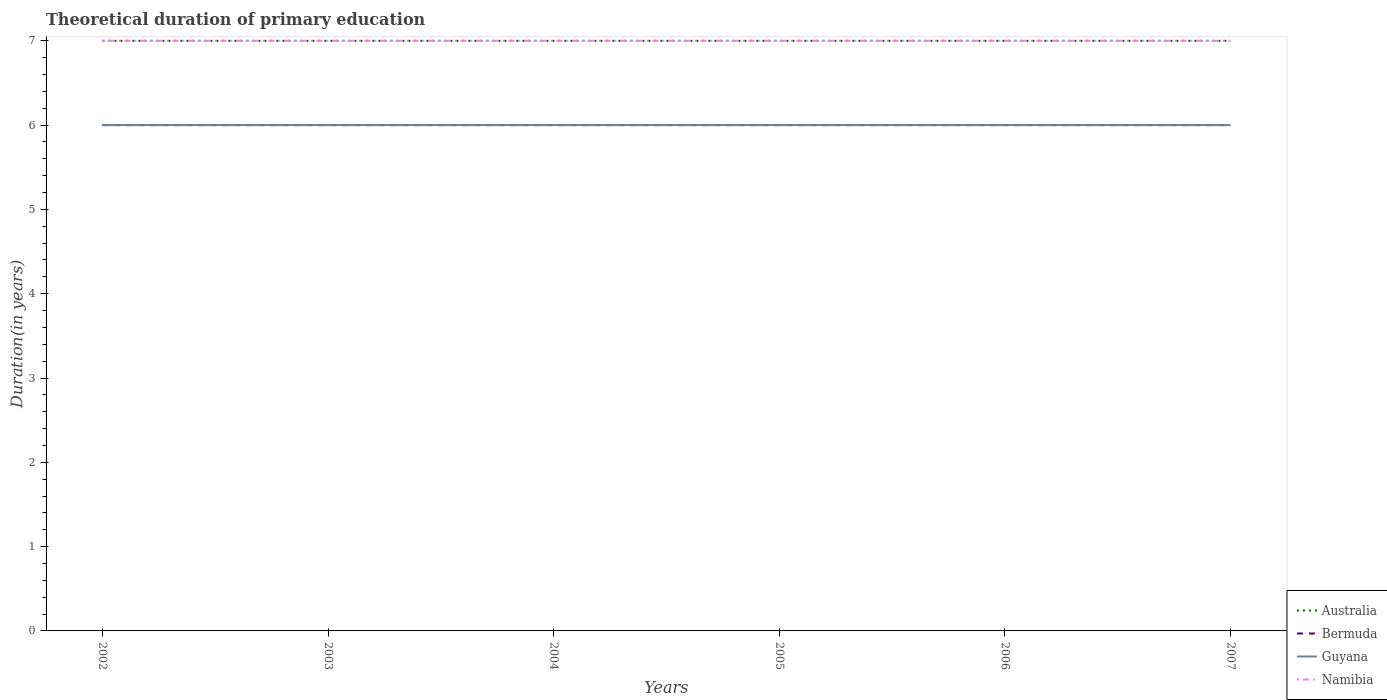How many different coloured lines are there?
Provide a succinct answer. 4. Does the line corresponding to Bermuda intersect with the line corresponding to Guyana?
Keep it short and to the point. Yes. Is the number of lines equal to the number of legend labels?
Your answer should be very brief. Yes. What is the total total theoretical duration of primary education in Australia in the graph?
Your answer should be very brief. 0. What is the difference between the highest and the lowest total theoretical duration of primary education in Bermuda?
Keep it short and to the point. 0. Is the total theoretical duration of primary education in Guyana strictly greater than the total theoretical duration of primary education in Namibia over the years?
Offer a terse response. Yes. How many lines are there?
Your response must be concise. 4. What is the difference between two consecutive major ticks on the Y-axis?
Provide a short and direct response. 1. Does the graph contain grids?
Provide a short and direct response. No. How are the legend labels stacked?
Make the answer very short. Vertical. What is the title of the graph?
Your response must be concise. Theoretical duration of primary education. Does "Canada" appear as one of the legend labels in the graph?
Give a very brief answer. No. What is the label or title of the X-axis?
Your answer should be very brief. Years. What is the label or title of the Y-axis?
Ensure brevity in your answer.  Duration(in years). What is the Duration(in years) in Australia in 2002?
Your answer should be very brief. 7. What is the Duration(in years) of Bermuda in 2002?
Provide a short and direct response. 6. What is the Duration(in years) of Guyana in 2002?
Offer a terse response. 6. What is the Duration(in years) in Australia in 2003?
Provide a short and direct response. 7. What is the Duration(in years) in Bermuda in 2004?
Your answer should be very brief. 6. What is the Duration(in years) of Australia in 2005?
Provide a succinct answer. 7. What is the Duration(in years) in Bermuda in 2005?
Make the answer very short. 6. What is the Duration(in years) of Guyana in 2005?
Your answer should be very brief. 6. What is the Duration(in years) of Namibia in 2005?
Offer a terse response. 7. What is the Duration(in years) of Bermuda in 2006?
Provide a succinct answer. 6. What is the Duration(in years) of Guyana in 2006?
Your response must be concise. 6. What is the Duration(in years) of Guyana in 2007?
Your response must be concise. 6. What is the Duration(in years) of Namibia in 2007?
Your response must be concise. 7. Across all years, what is the maximum Duration(in years) in Guyana?
Offer a very short reply. 6. Across all years, what is the minimum Duration(in years) of Guyana?
Your response must be concise. 6. What is the total Duration(in years) in Australia in the graph?
Provide a succinct answer. 42. What is the total Duration(in years) of Bermuda in the graph?
Provide a short and direct response. 36. What is the difference between the Duration(in years) in Namibia in 2002 and that in 2003?
Provide a succinct answer. 0. What is the difference between the Duration(in years) in Australia in 2002 and that in 2004?
Offer a very short reply. 0. What is the difference between the Duration(in years) in Bermuda in 2002 and that in 2004?
Give a very brief answer. 0. What is the difference between the Duration(in years) of Guyana in 2002 and that in 2004?
Your response must be concise. 0. What is the difference between the Duration(in years) in Australia in 2002 and that in 2005?
Make the answer very short. 0. What is the difference between the Duration(in years) in Bermuda in 2002 and that in 2005?
Provide a short and direct response. 0. What is the difference between the Duration(in years) in Guyana in 2002 and that in 2005?
Your answer should be compact. 0. What is the difference between the Duration(in years) of Australia in 2002 and that in 2006?
Ensure brevity in your answer.  0. What is the difference between the Duration(in years) of Australia in 2002 and that in 2007?
Your response must be concise. 0. What is the difference between the Duration(in years) in Guyana in 2002 and that in 2007?
Your answer should be compact. 0. What is the difference between the Duration(in years) of Australia in 2003 and that in 2004?
Your answer should be very brief. 0. What is the difference between the Duration(in years) in Bermuda in 2003 and that in 2004?
Offer a terse response. 0. What is the difference between the Duration(in years) of Guyana in 2003 and that in 2004?
Your answer should be compact. 0. What is the difference between the Duration(in years) of Namibia in 2003 and that in 2004?
Your response must be concise. 0. What is the difference between the Duration(in years) of Bermuda in 2003 and that in 2005?
Your answer should be very brief. 0. What is the difference between the Duration(in years) of Guyana in 2003 and that in 2005?
Provide a succinct answer. 0. What is the difference between the Duration(in years) in Namibia in 2003 and that in 2005?
Keep it short and to the point. 0. What is the difference between the Duration(in years) of Bermuda in 2003 and that in 2006?
Give a very brief answer. 0. What is the difference between the Duration(in years) in Namibia in 2003 and that in 2006?
Offer a very short reply. 0. What is the difference between the Duration(in years) of Bermuda in 2003 and that in 2007?
Your response must be concise. 0. What is the difference between the Duration(in years) of Namibia in 2003 and that in 2007?
Give a very brief answer. 0. What is the difference between the Duration(in years) of Australia in 2004 and that in 2005?
Give a very brief answer. 0. What is the difference between the Duration(in years) of Guyana in 2004 and that in 2005?
Offer a terse response. 0. What is the difference between the Duration(in years) in Bermuda in 2004 and that in 2006?
Provide a short and direct response. 0. What is the difference between the Duration(in years) of Australia in 2004 and that in 2007?
Offer a terse response. 0. What is the difference between the Duration(in years) of Namibia in 2004 and that in 2007?
Your answer should be compact. 0. What is the difference between the Duration(in years) in Bermuda in 2005 and that in 2006?
Provide a short and direct response. 0. What is the difference between the Duration(in years) of Guyana in 2005 and that in 2006?
Make the answer very short. 0. What is the difference between the Duration(in years) in Namibia in 2005 and that in 2006?
Offer a terse response. 0. What is the difference between the Duration(in years) of Guyana in 2005 and that in 2007?
Keep it short and to the point. 0. What is the difference between the Duration(in years) in Bermuda in 2006 and that in 2007?
Your answer should be compact. 0. What is the difference between the Duration(in years) in Guyana in 2006 and that in 2007?
Make the answer very short. 0. What is the difference between the Duration(in years) in Namibia in 2006 and that in 2007?
Keep it short and to the point. 0. What is the difference between the Duration(in years) of Australia in 2002 and the Duration(in years) of Bermuda in 2003?
Offer a terse response. 1. What is the difference between the Duration(in years) in Bermuda in 2002 and the Duration(in years) in Guyana in 2003?
Offer a terse response. 0. What is the difference between the Duration(in years) in Australia in 2002 and the Duration(in years) in Guyana in 2004?
Your answer should be very brief. 1. What is the difference between the Duration(in years) in Bermuda in 2002 and the Duration(in years) in Guyana in 2004?
Offer a very short reply. 0. What is the difference between the Duration(in years) in Bermuda in 2002 and the Duration(in years) in Namibia in 2004?
Your answer should be compact. -1. What is the difference between the Duration(in years) of Australia in 2002 and the Duration(in years) of Guyana in 2005?
Keep it short and to the point. 1. What is the difference between the Duration(in years) in Australia in 2002 and the Duration(in years) in Namibia in 2005?
Give a very brief answer. 0. What is the difference between the Duration(in years) of Bermuda in 2002 and the Duration(in years) of Namibia in 2005?
Offer a terse response. -1. What is the difference between the Duration(in years) in Guyana in 2002 and the Duration(in years) in Namibia in 2005?
Your answer should be very brief. -1. What is the difference between the Duration(in years) in Australia in 2002 and the Duration(in years) in Guyana in 2006?
Give a very brief answer. 1. What is the difference between the Duration(in years) of Bermuda in 2002 and the Duration(in years) of Guyana in 2006?
Offer a very short reply. 0. What is the difference between the Duration(in years) in Bermuda in 2002 and the Duration(in years) in Namibia in 2006?
Your answer should be compact. -1. What is the difference between the Duration(in years) in Australia in 2002 and the Duration(in years) in Namibia in 2007?
Provide a short and direct response. 0. What is the difference between the Duration(in years) in Bermuda in 2002 and the Duration(in years) in Namibia in 2007?
Provide a short and direct response. -1. What is the difference between the Duration(in years) in Guyana in 2002 and the Duration(in years) in Namibia in 2007?
Keep it short and to the point. -1. What is the difference between the Duration(in years) of Australia in 2003 and the Duration(in years) of Bermuda in 2004?
Offer a terse response. 1. What is the difference between the Duration(in years) of Australia in 2003 and the Duration(in years) of Guyana in 2004?
Keep it short and to the point. 1. What is the difference between the Duration(in years) in Australia in 2003 and the Duration(in years) in Guyana in 2005?
Offer a very short reply. 1. What is the difference between the Duration(in years) in Australia in 2003 and the Duration(in years) in Namibia in 2005?
Ensure brevity in your answer.  0. What is the difference between the Duration(in years) of Australia in 2003 and the Duration(in years) of Bermuda in 2006?
Ensure brevity in your answer.  1. What is the difference between the Duration(in years) in Australia in 2003 and the Duration(in years) in Guyana in 2006?
Your answer should be very brief. 1. What is the difference between the Duration(in years) of Australia in 2003 and the Duration(in years) of Namibia in 2006?
Your answer should be very brief. 0. What is the difference between the Duration(in years) of Guyana in 2003 and the Duration(in years) of Namibia in 2006?
Keep it short and to the point. -1. What is the difference between the Duration(in years) in Australia in 2003 and the Duration(in years) in Bermuda in 2007?
Offer a very short reply. 1. What is the difference between the Duration(in years) in Bermuda in 2003 and the Duration(in years) in Guyana in 2007?
Make the answer very short. 0. What is the difference between the Duration(in years) of Bermuda in 2003 and the Duration(in years) of Namibia in 2007?
Offer a very short reply. -1. What is the difference between the Duration(in years) of Guyana in 2003 and the Duration(in years) of Namibia in 2007?
Offer a terse response. -1. What is the difference between the Duration(in years) of Australia in 2004 and the Duration(in years) of Bermuda in 2005?
Keep it short and to the point. 1. What is the difference between the Duration(in years) of Australia in 2004 and the Duration(in years) of Guyana in 2005?
Offer a very short reply. 1. What is the difference between the Duration(in years) in Australia in 2004 and the Duration(in years) in Namibia in 2006?
Ensure brevity in your answer.  0. What is the difference between the Duration(in years) in Bermuda in 2004 and the Duration(in years) in Guyana in 2006?
Provide a short and direct response. 0. What is the difference between the Duration(in years) in Bermuda in 2004 and the Duration(in years) in Namibia in 2006?
Keep it short and to the point. -1. What is the difference between the Duration(in years) of Australia in 2004 and the Duration(in years) of Guyana in 2007?
Your response must be concise. 1. What is the difference between the Duration(in years) in Australia in 2004 and the Duration(in years) in Namibia in 2007?
Offer a terse response. 0. What is the difference between the Duration(in years) of Bermuda in 2004 and the Duration(in years) of Namibia in 2007?
Keep it short and to the point. -1. What is the difference between the Duration(in years) in Australia in 2005 and the Duration(in years) in Namibia in 2006?
Your answer should be very brief. 0. What is the difference between the Duration(in years) of Bermuda in 2005 and the Duration(in years) of Guyana in 2006?
Your response must be concise. 0. What is the difference between the Duration(in years) of Guyana in 2005 and the Duration(in years) of Namibia in 2006?
Keep it short and to the point. -1. What is the difference between the Duration(in years) of Australia in 2005 and the Duration(in years) of Guyana in 2007?
Provide a short and direct response. 1. What is the difference between the Duration(in years) in Australia in 2005 and the Duration(in years) in Namibia in 2007?
Your answer should be very brief. 0. What is the difference between the Duration(in years) of Bermuda in 2005 and the Duration(in years) of Guyana in 2007?
Give a very brief answer. 0. What is the difference between the Duration(in years) in Bermuda in 2005 and the Duration(in years) in Namibia in 2007?
Offer a terse response. -1. What is the difference between the Duration(in years) in Australia in 2006 and the Duration(in years) in Bermuda in 2007?
Your answer should be compact. 1. What is the difference between the Duration(in years) in Guyana in 2006 and the Duration(in years) in Namibia in 2007?
Offer a terse response. -1. What is the average Duration(in years) in Guyana per year?
Offer a terse response. 6. In the year 2002, what is the difference between the Duration(in years) in Australia and Duration(in years) in Namibia?
Your response must be concise. 0. In the year 2002, what is the difference between the Duration(in years) of Guyana and Duration(in years) of Namibia?
Your answer should be very brief. -1. In the year 2003, what is the difference between the Duration(in years) in Australia and Duration(in years) in Bermuda?
Offer a very short reply. 1. In the year 2003, what is the difference between the Duration(in years) in Bermuda and Duration(in years) in Namibia?
Ensure brevity in your answer.  -1. In the year 2003, what is the difference between the Duration(in years) in Guyana and Duration(in years) in Namibia?
Your answer should be very brief. -1. In the year 2004, what is the difference between the Duration(in years) of Australia and Duration(in years) of Bermuda?
Your answer should be very brief. 1. In the year 2004, what is the difference between the Duration(in years) of Australia and Duration(in years) of Guyana?
Keep it short and to the point. 1. In the year 2004, what is the difference between the Duration(in years) of Australia and Duration(in years) of Namibia?
Your answer should be very brief. 0. In the year 2004, what is the difference between the Duration(in years) in Bermuda and Duration(in years) in Namibia?
Your answer should be very brief. -1. In the year 2005, what is the difference between the Duration(in years) in Australia and Duration(in years) in Bermuda?
Keep it short and to the point. 1. In the year 2005, what is the difference between the Duration(in years) of Australia and Duration(in years) of Guyana?
Your response must be concise. 1. In the year 2005, what is the difference between the Duration(in years) in Australia and Duration(in years) in Namibia?
Offer a terse response. 0. In the year 2005, what is the difference between the Duration(in years) of Guyana and Duration(in years) of Namibia?
Offer a terse response. -1. In the year 2006, what is the difference between the Duration(in years) of Australia and Duration(in years) of Bermuda?
Your answer should be very brief. 1. In the year 2006, what is the difference between the Duration(in years) in Bermuda and Duration(in years) in Guyana?
Offer a terse response. 0. In the year 2006, what is the difference between the Duration(in years) of Bermuda and Duration(in years) of Namibia?
Offer a terse response. -1. In the year 2006, what is the difference between the Duration(in years) in Guyana and Duration(in years) in Namibia?
Offer a terse response. -1. In the year 2007, what is the difference between the Duration(in years) of Australia and Duration(in years) of Guyana?
Your answer should be very brief. 1. In the year 2007, what is the difference between the Duration(in years) of Australia and Duration(in years) of Namibia?
Ensure brevity in your answer.  0. In the year 2007, what is the difference between the Duration(in years) of Bermuda and Duration(in years) of Namibia?
Offer a very short reply. -1. In the year 2007, what is the difference between the Duration(in years) in Guyana and Duration(in years) in Namibia?
Ensure brevity in your answer.  -1. What is the ratio of the Duration(in years) in Guyana in 2002 to that in 2003?
Ensure brevity in your answer.  1. What is the ratio of the Duration(in years) in Namibia in 2002 to that in 2003?
Your response must be concise. 1. What is the ratio of the Duration(in years) in Guyana in 2002 to that in 2005?
Keep it short and to the point. 1. What is the ratio of the Duration(in years) in Namibia in 2002 to that in 2005?
Keep it short and to the point. 1. What is the ratio of the Duration(in years) in Bermuda in 2002 to that in 2006?
Your response must be concise. 1. What is the ratio of the Duration(in years) of Guyana in 2002 to that in 2006?
Ensure brevity in your answer.  1. What is the ratio of the Duration(in years) of Namibia in 2002 to that in 2006?
Your answer should be compact. 1. What is the ratio of the Duration(in years) of Bermuda in 2002 to that in 2007?
Provide a succinct answer. 1. What is the ratio of the Duration(in years) in Namibia in 2002 to that in 2007?
Give a very brief answer. 1. What is the ratio of the Duration(in years) of Australia in 2003 to that in 2004?
Keep it short and to the point. 1. What is the ratio of the Duration(in years) of Guyana in 2003 to that in 2004?
Keep it short and to the point. 1. What is the ratio of the Duration(in years) of Guyana in 2003 to that in 2005?
Make the answer very short. 1. What is the ratio of the Duration(in years) of Australia in 2003 to that in 2006?
Provide a short and direct response. 1. What is the ratio of the Duration(in years) in Guyana in 2003 to that in 2006?
Ensure brevity in your answer.  1. What is the ratio of the Duration(in years) in Namibia in 2003 to that in 2006?
Offer a very short reply. 1. What is the ratio of the Duration(in years) in Bermuda in 2003 to that in 2007?
Your response must be concise. 1. What is the ratio of the Duration(in years) in Bermuda in 2004 to that in 2005?
Keep it short and to the point. 1. What is the ratio of the Duration(in years) in Guyana in 2004 to that in 2005?
Ensure brevity in your answer.  1. What is the ratio of the Duration(in years) in Australia in 2004 to that in 2006?
Your answer should be compact. 1. What is the ratio of the Duration(in years) in Guyana in 2004 to that in 2006?
Your response must be concise. 1. What is the ratio of the Duration(in years) in Australia in 2005 to that in 2006?
Ensure brevity in your answer.  1. What is the ratio of the Duration(in years) in Guyana in 2005 to that in 2006?
Provide a short and direct response. 1. What is the ratio of the Duration(in years) in Namibia in 2005 to that in 2006?
Your response must be concise. 1. What is the ratio of the Duration(in years) in Namibia in 2005 to that in 2007?
Give a very brief answer. 1. What is the ratio of the Duration(in years) of Bermuda in 2006 to that in 2007?
Make the answer very short. 1. What is the ratio of the Duration(in years) of Guyana in 2006 to that in 2007?
Ensure brevity in your answer.  1. What is the ratio of the Duration(in years) in Namibia in 2006 to that in 2007?
Your answer should be compact. 1. What is the difference between the highest and the second highest Duration(in years) in Bermuda?
Make the answer very short. 0. What is the difference between the highest and the second highest Duration(in years) in Guyana?
Your response must be concise. 0. What is the difference between the highest and the lowest Duration(in years) of Australia?
Ensure brevity in your answer.  0. What is the difference between the highest and the lowest Duration(in years) in Namibia?
Provide a succinct answer. 0. 